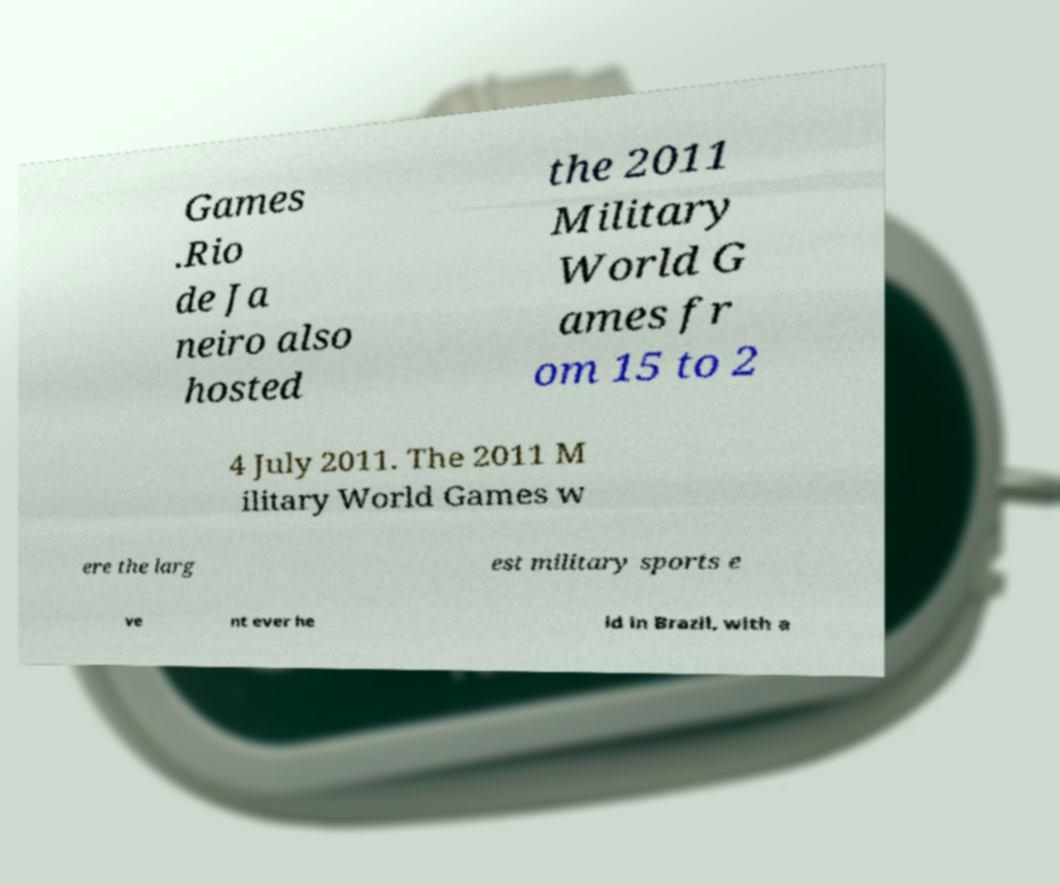Can you read and provide the text displayed in the image?This photo seems to have some interesting text. Can you extract and type it out for me? Games .Rio de Ja neiro also hosted the 2011 Military World G ames fr om 15 to 2 4 July 2011. The 2011 M ilitary World Games w ere the larg est military sports e ve nt ever he ld in Brazil, with a 